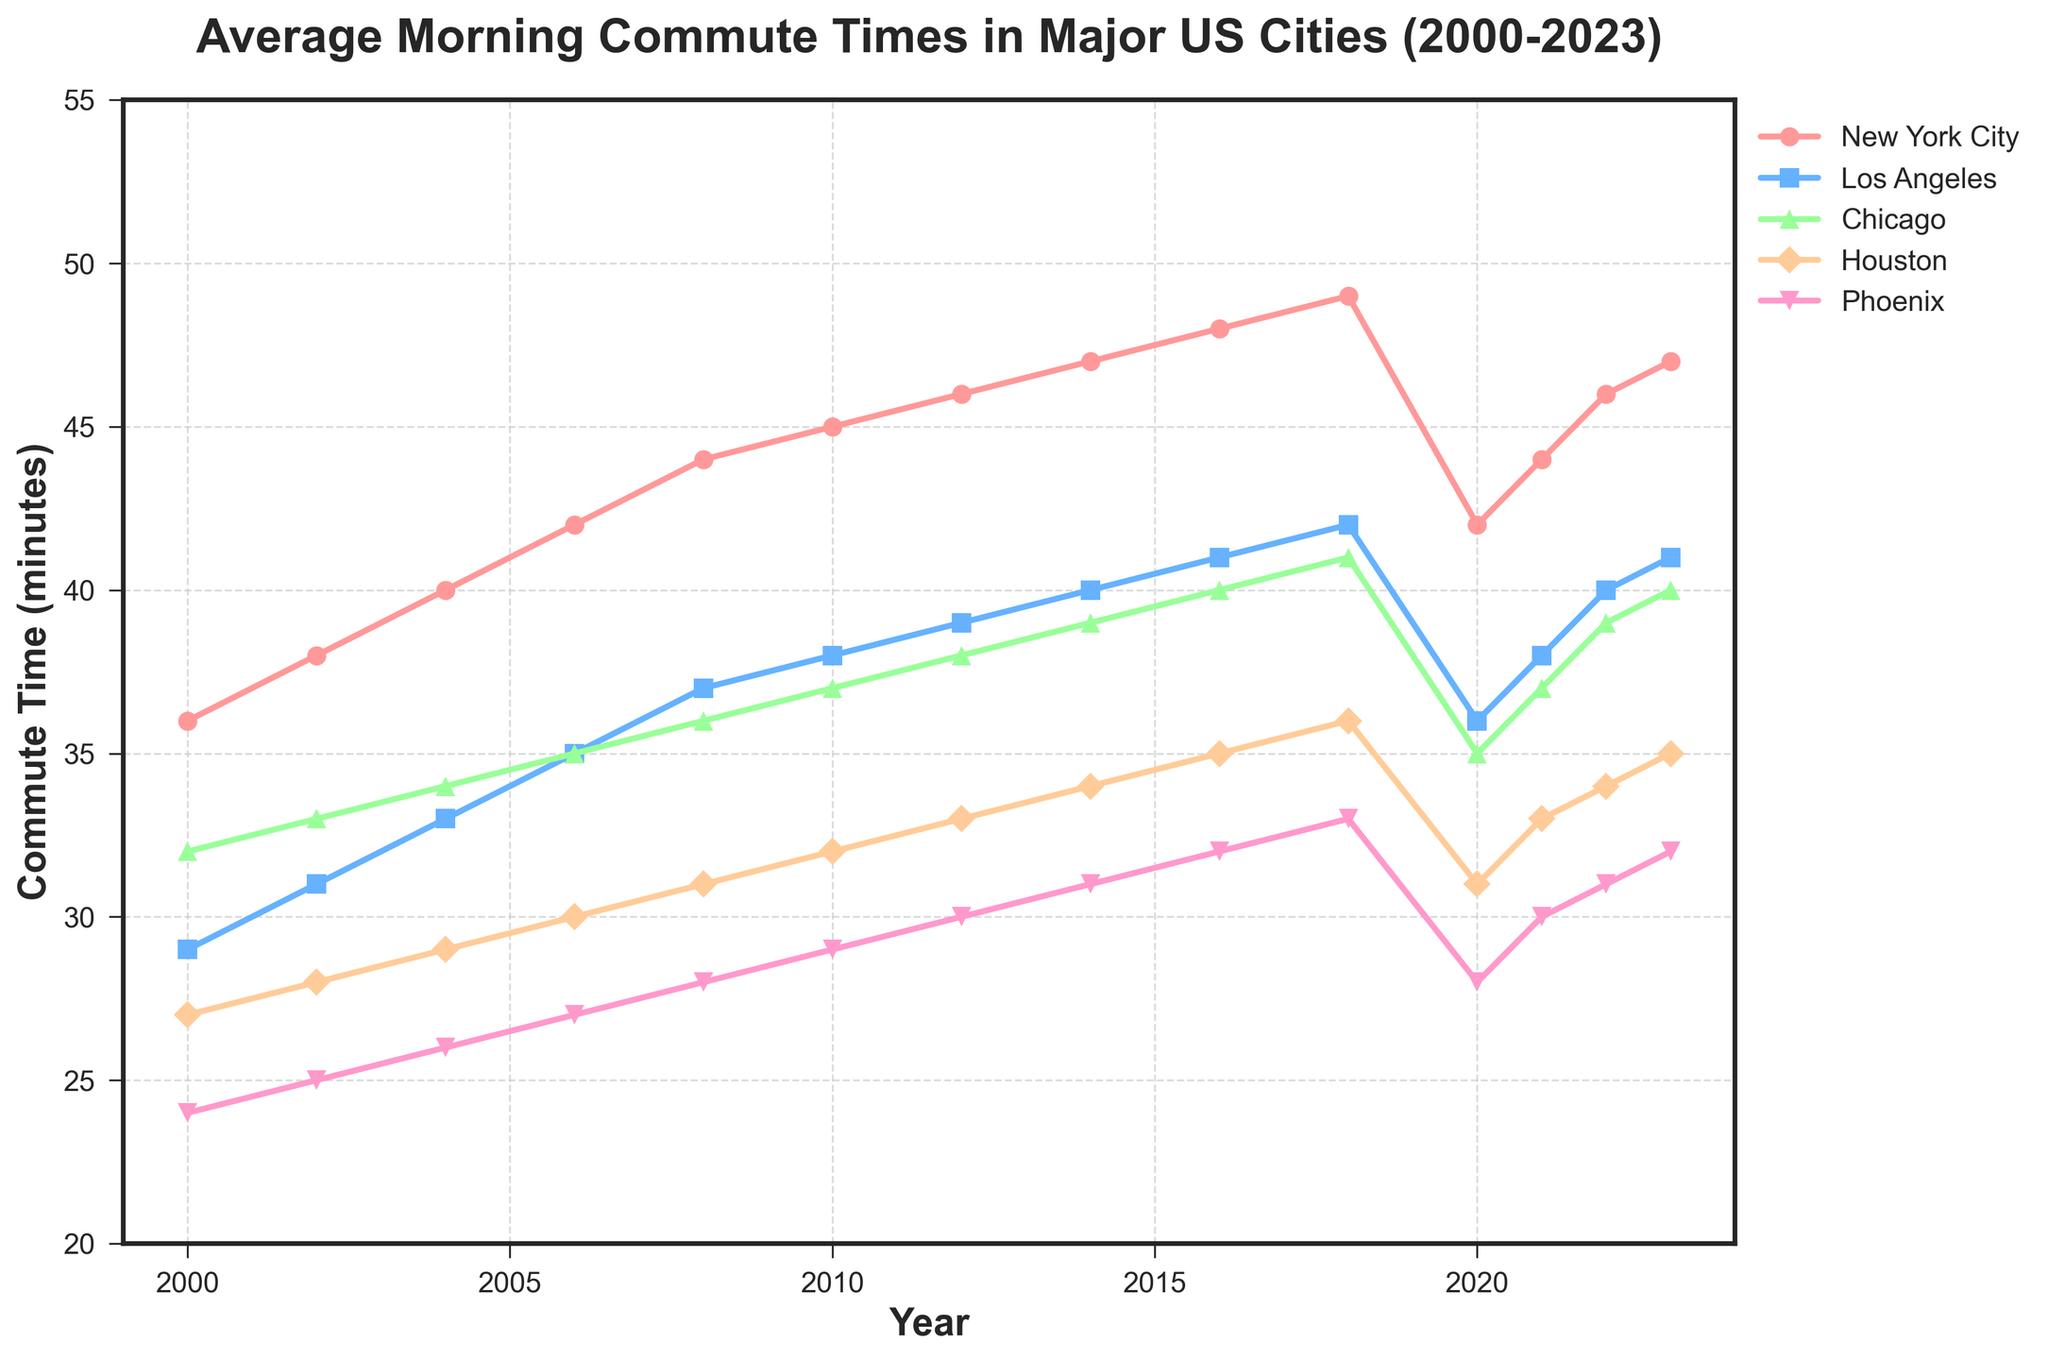What's the average morning commute time for New York City in 2023? The figure shows that the commute time for New York City in 2023 is represented by a specific point on the line chart.
Answer: 47 minutes Which city had the shortest average morning commute time in 2000? By looking at the figure and comparing the heights of the markers for the year 2000, we can identify the shortest commute time.
Answer: Phoenix How much did the average morning commute time increase in Chicago from 2000 to 2018? The commute time in Chicago was 32 minutes in 2000 and 41 minutes in 2018. The increase is found by subtracting 32 from 41.
Answer: 9 minutes In which year did New York City experience a significant drop in commute time, and how much was the decrease? The figure shows a noticeable drop in the New York City line around 2020. From 2018 to 2020, the commute time decreased from 49 minutes to 42 minutes.
Answer: 2020, 7 minutes Which city had the highest average morning commute time in 2023? By identifying the tallest marker for 2023 across all the lines, we can determine the city with the highest commute time.
Answer: New York City Which year had the closest commute times for Houston and Phoenix? By visually comparing the lines for Houston and Phoenix, we can find the year where the markers for both cities are closest to each other.
Answer: 2020 How many years did it take for Los Angeles to increase its average commute time from 29 to 41 minutes? By finding the initial and final points where Los Angeles had commute times of 29 minutes and 41 minutes, respectively, and calculating the year difference.
Answer: 16 years (2000 to 2016) Between 2010 and 2020, which city showed the least amount of change in average morning commute time? By comparing the lengths of the vertical changes of the lines for each city between 2010 and 2020, the city with the smallest change is identified.
Answer: Phoenix 